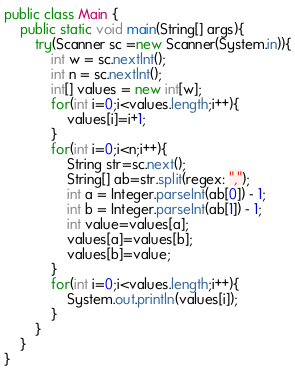Convert code to text. <code><loc_0><loc_0><loc_500><loc_500><_Java_>public class Main {
    public static void main(String[] args){
        try(Scanner sc =new Scanner(System.in)){
            int w = sc.nextlnt();
            int n = sc.nextlnt();
            int[] values = new int[w];
            for(int i=0;i<values.length;i++){
                values[i]=i+1;
            }
            for(int i=0;i<n;i++){
                String str=sc.next();
                String[] ab=str.split(regex: ",");
                int a = Integer.parseInt(ab[0]) - 1;
                int b = Integer.parseInt(ab[1]) - 1;
                int value=values[a];
                values[a]=values[b];
                values[b]=value;
            }
            for(int i=0;i<values.length;i++){
                System.out.println(values[i]);
            }
        }
    }
}
</code> 